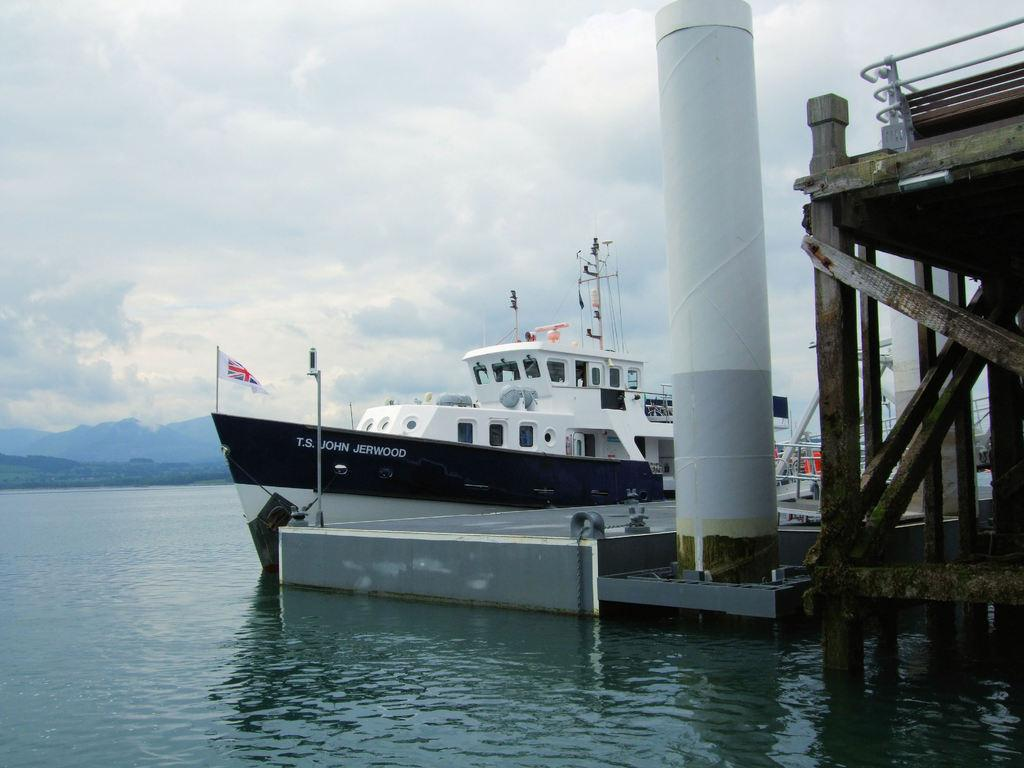<image>
Summarize the visual content of the image. The T.S. John Jerwood is pulled up to the dock and is flying a British flag. 